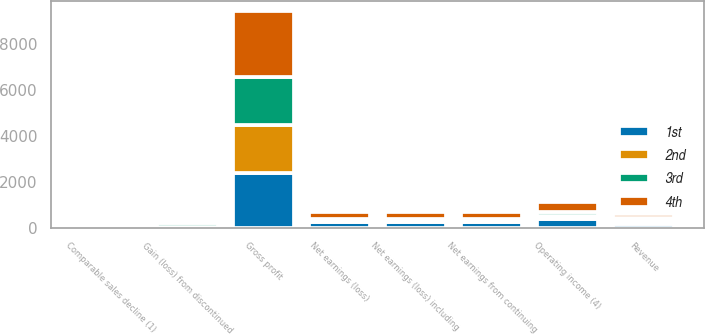<chart> <loc_0><loc_0><loc_500><loc_500><stacked_bar_chart><ecel><fcel>Revenue<fcel>Comparable sales decline (1)<fcel>Gross profit<fcel>Operating income (4)<fcel>Net earnings from continuing<fcel>Gain (loss) from discontinued<fcel>Net earnings (loss) including<fcel>Net earnings (loss)<nl><fcel>3rd<fcel>148.5<fcel>1.8<fcel>2105<fcel>187<fcel>112<fcel>185<fcel>73<fcel>81<nl><fcel>1st<fcel>148.5<fcel>0.6<fcel>2373<fcel>405<fcel>233<fcel>15<fcel>248<fcel>266<nl><fcel>2nd<fcel>148.5<fcel>0.5<fcel>2093<fcel>100<fcel>50<fcel>4<fcel>54<fcel>54<nl><fcel>4th<fcel>148.5<fcel>1.3<fcel>2828<fcel>452<fcel>300<fcel>6<fcel>294<fcel>293<nl></chart> 